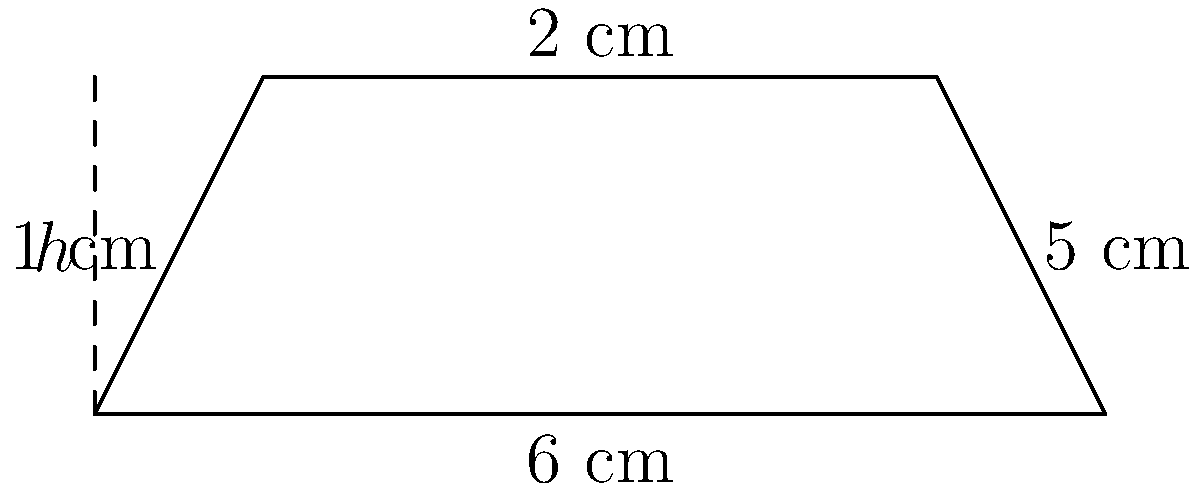In your custom progress bar design, you're using a trapezoid shape. The trapezoid has parallel sides of 6 cm and 2 cm, with a height of 2 cm. What is the area of this trapezoid in square centimeters? To find the area of a trapezoid, we use the formula:

$$A = \frac{1}{2}(b_1 + b_2)h$$

Where:
$A$ = Area
$b_1$ = Length of one parallel side
$b_2$ = Length of the other parallel side
$h$ = Height of the trapezoid

Given:
$b_1 = 6$ cm
$b_2 = 2$ cm
$h = 2$ cm

Let's substitute these values into the formula:

$$A = \frac{1}{2}(6 + 2) \times 2$$

$$A = \frac{1}{2}(8) \times 2$$

$$A = 4 \times 2$$

$$A = 8$$

Therefore, the area of the trapezoid is 8 square centimeters.
Answer: 8 cm² 